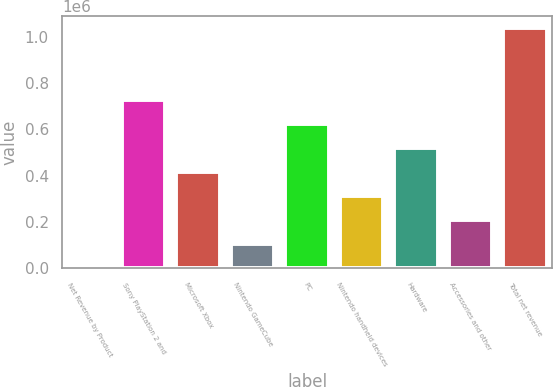Convert chart. <chart><loc_0><loc_0><loc_500><loc_500><bar_chart><fcel>Net Revenue by Product<fcel>Sony PlayStation 2 and<fcel>Microsoft Xbox<fcel>Nintendo GameCube<fcel>PC<fcel>Nintendo handheld devices<fcel>Hardware<fcel>Accessories and other<fcel>Total net revenue<nl><fcel>2006<fcel>727090<fcel>416340<fcel>105589<fcel>623506<fcel>312756<fcel>519923<fcel>209173<fcel>1.03784e+06<nl></chart> 